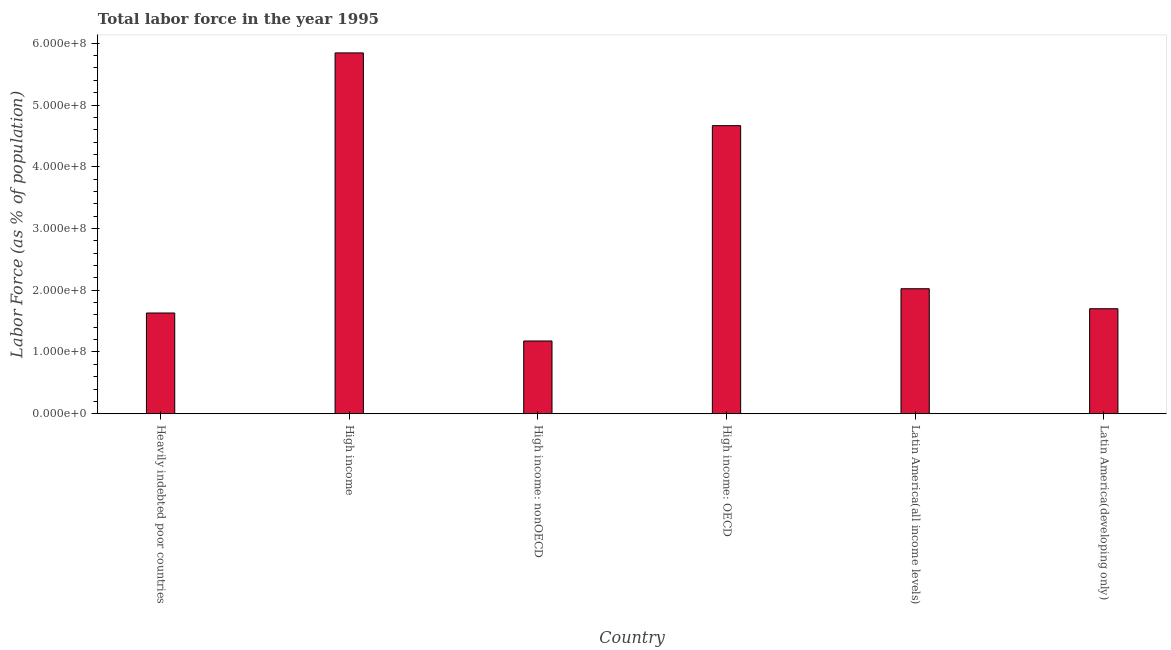Does the graph contain any zero values?
Offer a very short reply. No. Does the graph contain grids?
Give a very brief answer. No. What is the title of the graph?
Your answer should be very brief. Total labor force in the year 1995. What is the label or title of the Y-axis?
Provide a succinct answer. Labor Force (as % of population). What is the total labor force in Heavily indebted poor countries?
Provide a short and direct response. 1.63e+08. Across all countries, what is the maximum total labor force?
Offer a terse response. 5.84e+08. Across all countries, what is the minimum total labor force?
Your response must be concise. 1.18e+08. In which country was the total labor force minimum?
Give a very brief answer. High income: nonOECD. What is the sum of the total labor force?
Offer a terse response. 1.70e+09. What is the difference between the total labor force in Heavily indebted poor countries and High income: OECD?
Offer a very short reply. -3.03e+08. What is the average total labor force per country?
Provide a succinct answer. 2.84e+08. What is the median total labor force?
Provide a succinct answer. 1.86e+08. What is the ratio of the total labor force in High income: OECD to that in High income: nonOECD?
Give a very brief answer. 3.96. Is the total labor force in High income less than that in High income: nonOECD?
Your answer should be compact. No. What is the difference between the highest and the second highest total labor force?
Your answer should be very brief. 1.18e+08. What is the difference between the highest and the lowest total labor force?
Give a very brief answer. 4.67e+08. In how many countries, is the total labor force greater than the average total labor force taken over all countries?
Offer a very short reply. 2. How many bars are there?
Keep it short and to the point. 6. Are all the bars in the graph horizontal?
Offer a terse response. No. How many countries are there in the graph?
Provide a short and direct response. 6. What is the Labor Force (as % of population) of Heavily indebted poor countries?
Offer a terse response. 1.63e+08. What is the Labor Force (as % of population) in High income?
Ensure brevity in your answer.  5.84e+08. What is the Labor Force (as % of population) in High income: nonOECD?
Your answer should be compact. 1.18e+08. What is the Labor Force (as % of population) in High income: OECD?
Provide a short and direct response. 4.67e+08. What is the Labor Force (as % of population) in Latin America(all income levels)?
Ensure brevity in your answer.  2.02e+08. What is the Labor Force (as % of population) of Latin America(developing only)?
Provide a short and direct response. 1.70e+08. What is the difference between the Labor Force (as % of population) in Heavily indebted poor countries and High income?
Keep it short and to the point. -4.21e+08. What is the difference between the Labor Force (as % of population) in Heavily indebted poor countries and High income: nonOECD?
Give a very brief answer. 4.53e+07. What is the difference between the Labor Force (as % of population) in Heavily indebted poor countries and High income: OECD?
Keep it short and to the point. -3.03e+08. What is the difference between the Labor Force (as % of population) in Heavily indebted poor countries and Latin America(all income levels)?
Ensure brevity in your answer.  -3.93e+07. What is the difference between the Labor Force (as % of population) in Heavily indebted poor countries and Latin America(developing only)?
Your response must be concise. -6.90e+06. What is the difference between the Labor Force (as % of population) in High income and High income: nonOECD?
Keep it short and to the point. 4.67e+08. What is the difference between the Labor Force (as % of population) in High income and High income: OECD?
Your answer should be compact. 1.18e+08. What is the difference between the Labor Force (as % of population) in High income and Latin America(all income levels)?
Give a very brief answer. 3.82e+08. What is the difference between the Labor Force (as % of population) in High income and Latin America(developing only)?
Your answer should be compact. 4.14e+08. What is the difference between the Labor Force (as % of population) in High income: nonOECD and High income: OECD?
Your answer should be compact. -3.49e+08. What is the difference between the Labor Force (as % of population) in High income: nonOECD and Latin America(all income levels)?
Your answer should be very brief. -8.46e+07. What is the difference between the Labor Force (as % of population) in High income: nonOECD and Latin America(developing only)?
Your answer should be very brief. -5.22e+07. What is the difference between the Labor Force (as % of population) in High income: OECD and Latin America(all income levels)?
Provide a succinct answer. 2.64e+08. What is the difference between the Labor Force (as % of population) in High income: OECD and Latin America(developing only)?
Keep it short and to the point. 2.97e+08. What is the difference between the Labor Force (as % of population) in Latin America(all income levels) and Latin America(developing only)?
Ensure brevity in your answer.  3.24e+07. What is the ratio of the Labor Force (as % of population) in Heavily indebted poor countries to that in High income?
Your answer should be very brief. 0.28. What is the ratio of the Labor Force (as % of population) in Heavily indebted poor countries to that in High income: nonOECD?
Provide a succinct answer. 1.39. What is the ratio of the Labor Force (as % of population) in Heavily indebted poor countries to that in Latin America(all income levels)?
Keep it short and to the point. 0.81. What is the ratio of the Labor Force (as % of population) in High income to that in High income: nonOECD?
Your response must be concise. 4.96. What is the ratio of the Labor Force (as % of population) in High income to that in High income: OECD?
Your answer should be compact. 1.25. What is the ratio of the Labor Force (as % of population) in High income to that in Latin America(all income levels)?
Provide a short and direct response. 2.89. What is the ratio of the Labor Force (as % of population) in High income to that in Latin America(developing only)?
Make the answer very short. 3.44. What is the ratio of the Labor Force (as % of population) in High income: nonOECD to that in High income: OECD?
Offer a very short reply. 0.25. What is the ratio of the Labor Force (as % of population) in High income: nonOECD to that in Latin America(all income levels)?
Your answer should be compact. 0.58. What is the ratio of the Labor Force (as % of population) in High income: nonOECD to that in Latin America(developing only)?
Give a very brief answer. 0.69. What is the ratio of the Labor Force (as % of population) in High income: OECD to that in Latin America(all income levels)?
Make the answer very short. 2.31. What is the ratio of the Labor Force (as % of population) in High income: OECD to that in Latin America(developing only)?
Offer a terse response. 2.74. What is the ratio of the Labor Force (as % of population) in Latin America(all income levels) to that in Latin America(developing only)?
Make the answer very short. 1.19. 